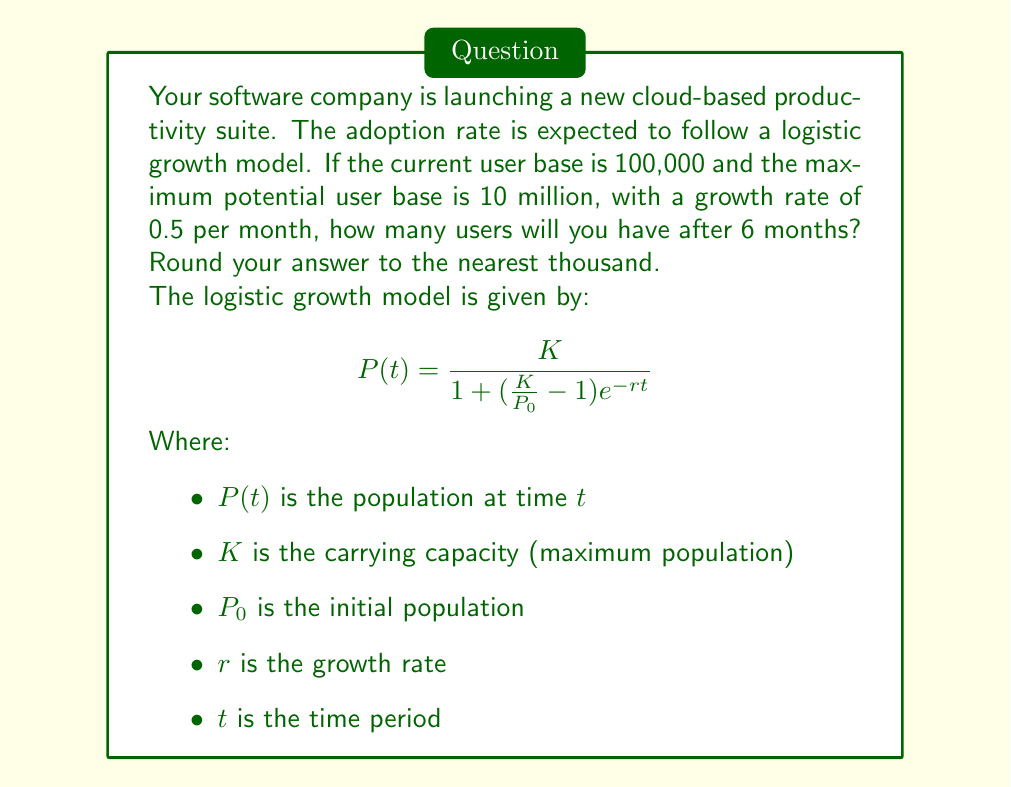Solve this math problem. Let's solve this step-by-step:

1) We are given:
   $K = 10,000,000$ (maximum potential user base)
   $P_0 = 100,000$ (current user base)
   $r = 0.5$ (growth rate per month)
   $t = 6$ (months)

2) Let's substitute these values into the logistic growth model:

   $$P(6) = \frac{10,000,000}{1 + (\frac{10,000,000}{100,000} - 1)e^{-0.5 \cdot 6}}$$

3) Simplify the fraction inside the parentheses:
   
   $$P(6) = \frac{10,000,000}{1 + (100 - 1)e^{-3}}$$

4) Calculate $e^{-3}$:
   
   $$P(6) = \frac{10,000,000}{1 + 99 \cdot 0.0497870684}$$

5) Multiply inside the parentheses:
   
   $$P(6) = \frac{10,000,000}{1 + 4.9289197716}$$

6) Add in the denominator:
   
   $$P(6) = \frac{10,000,000}{5.9289197716}$$

7) Divide:
   
   $$P(6) = 1,686,637.95$$

8) Rounding to the nearest thousand:
   
   $$P(6) \approx 1,687,000$$
Answer: 1,687,000 users 